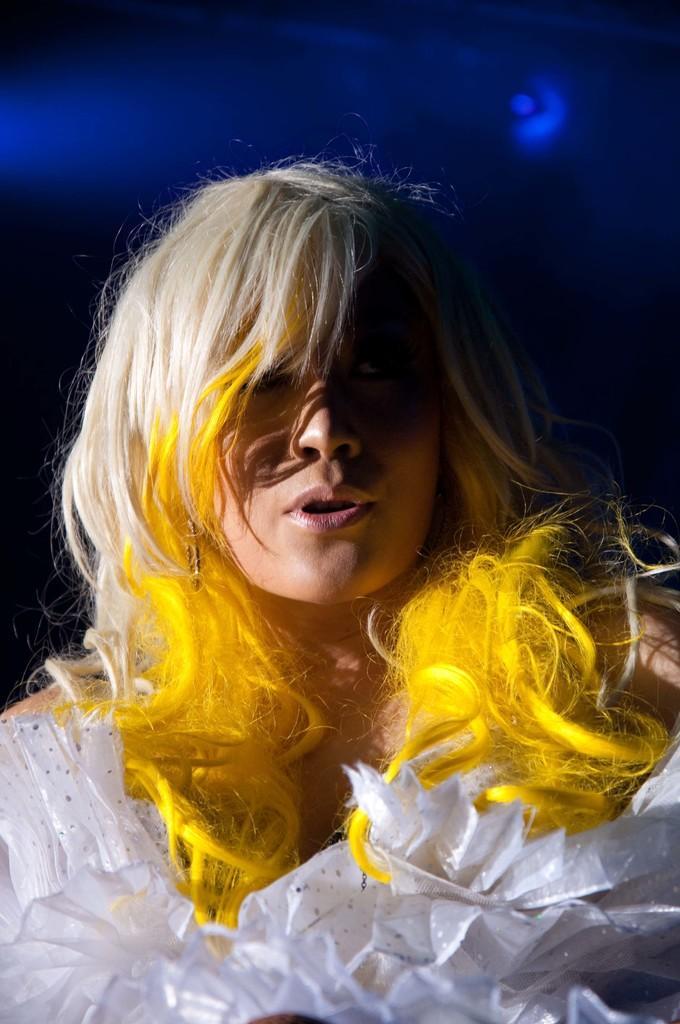Can you describe this image briefly? In the image we can see a woman wearing clothes and earrings, and the background is dark with blue lights. 